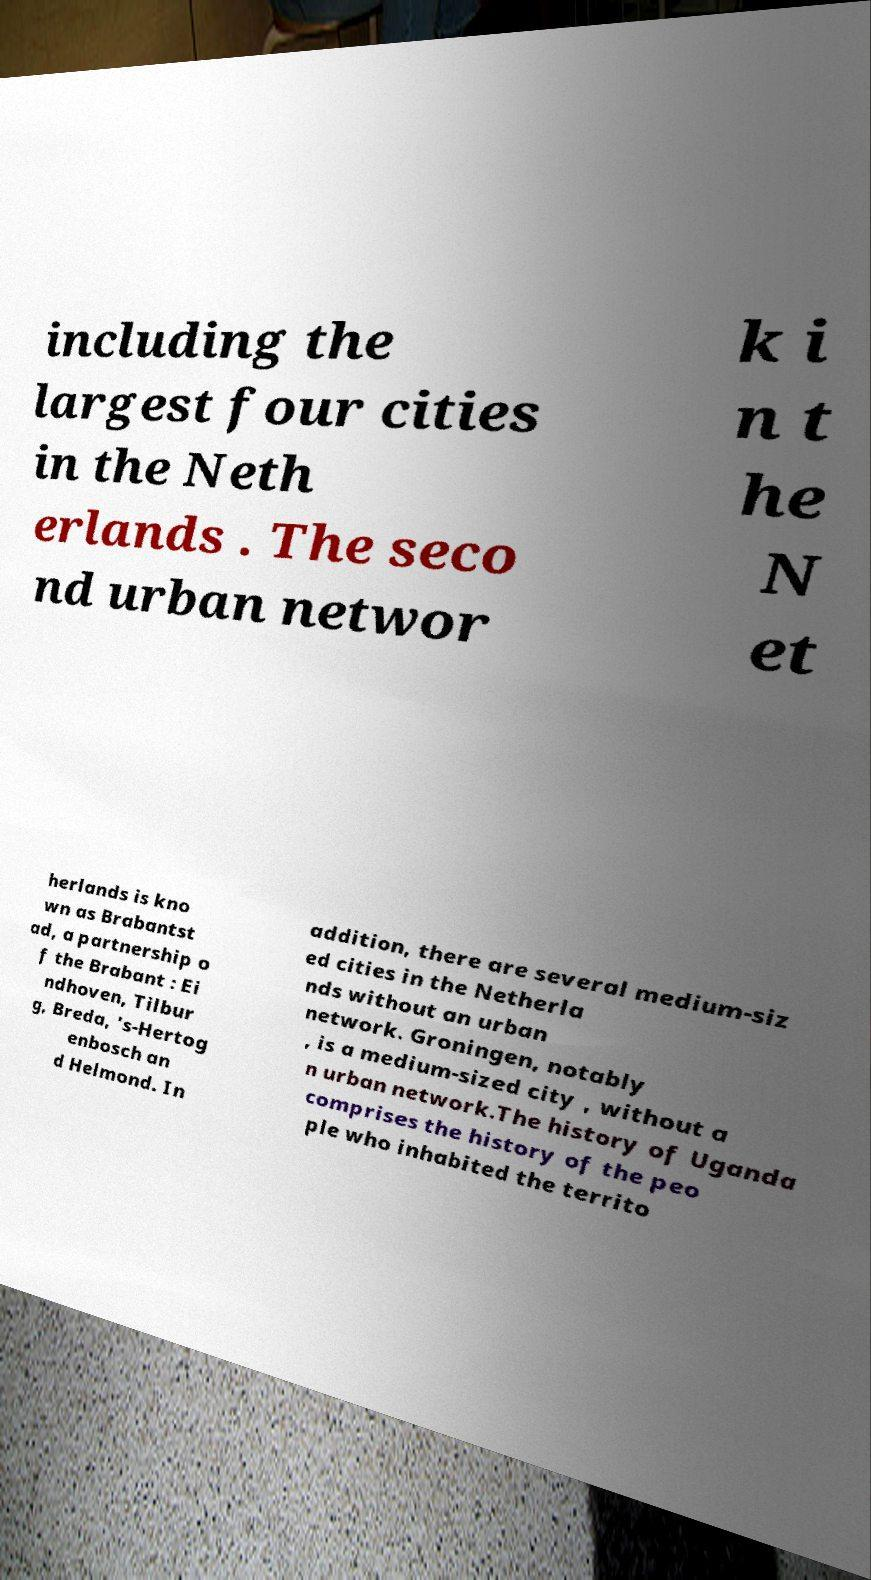Could you assist in decoding the text presented in this image and type it out clearly? including the largest four cities in the Neth erlands . The seco nd urban networ k i n t he N et herlands is kno wn as Brabantst ad, a partnership o f the Brabant : Ei ndhoven, Tilbur g, Breda, 's-Hertog enbosch an d Helmond. In addition, there are several medium-siz ed cities in the Netherla nds without an urban network. Groningen, notably , is a medium-sized city , without a n urban network.The history of Uganda comprises the history of the peo ple who inhabited the territo 